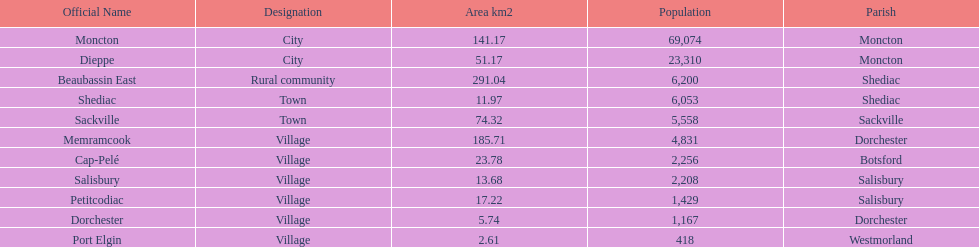Which city possesses the smallest area? Port Elgin. 